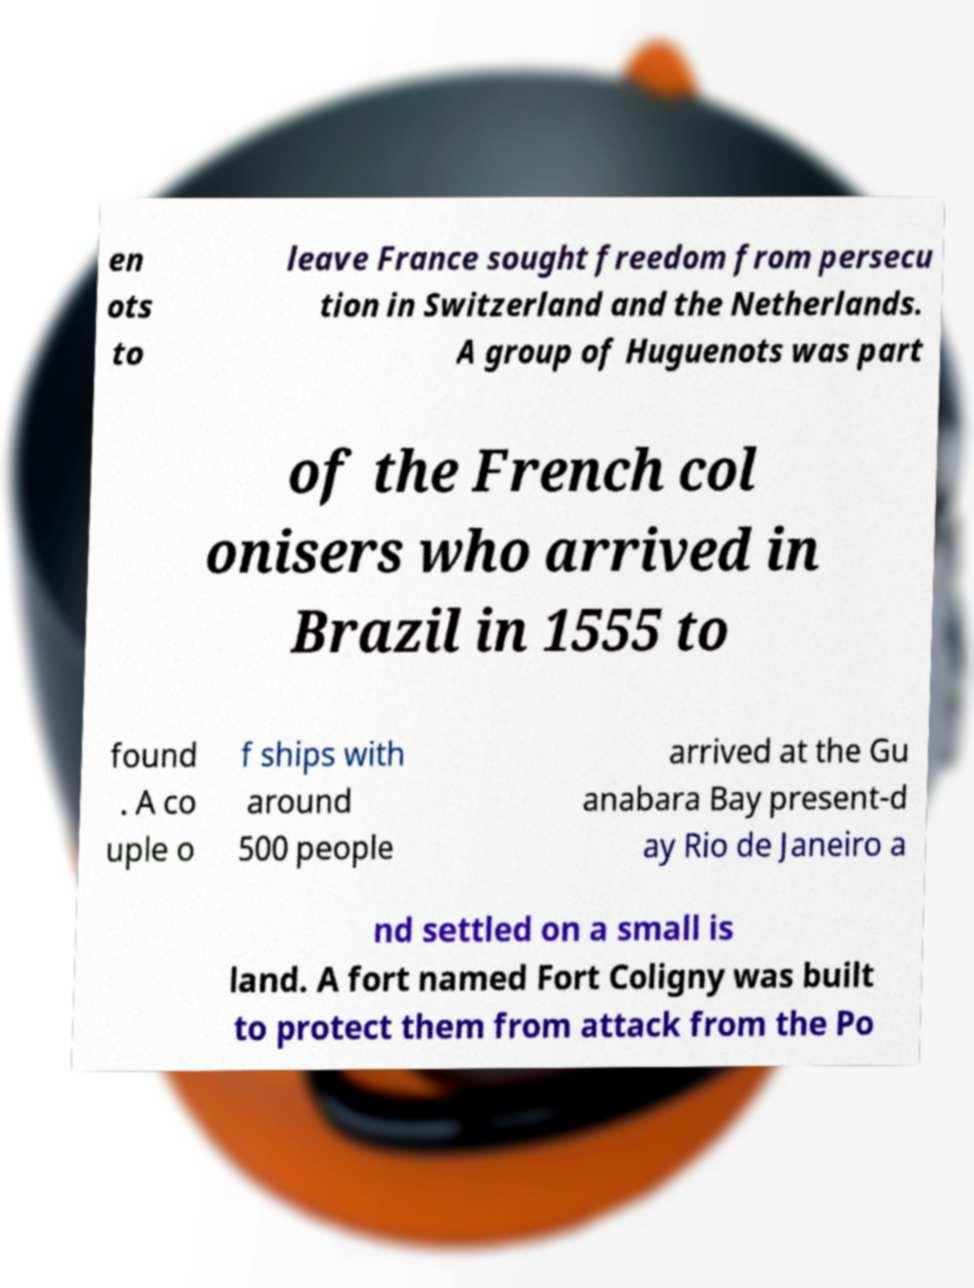Can you accurately transcribe the text from the provided image for me? en ots to leave France sought freedom from persecu tion in Switzerland and the Netherlands. A group of Huguenots was part of the French col onisers who arrived in Brazil in 1555 to found . A co uple o f ships with around 500 people arrived at the Gu anabara Bay present-d ay Rio de Janeiro a nd settled on a small is land. A fort named Fort Coligny was built to protect them from attack from the Po 